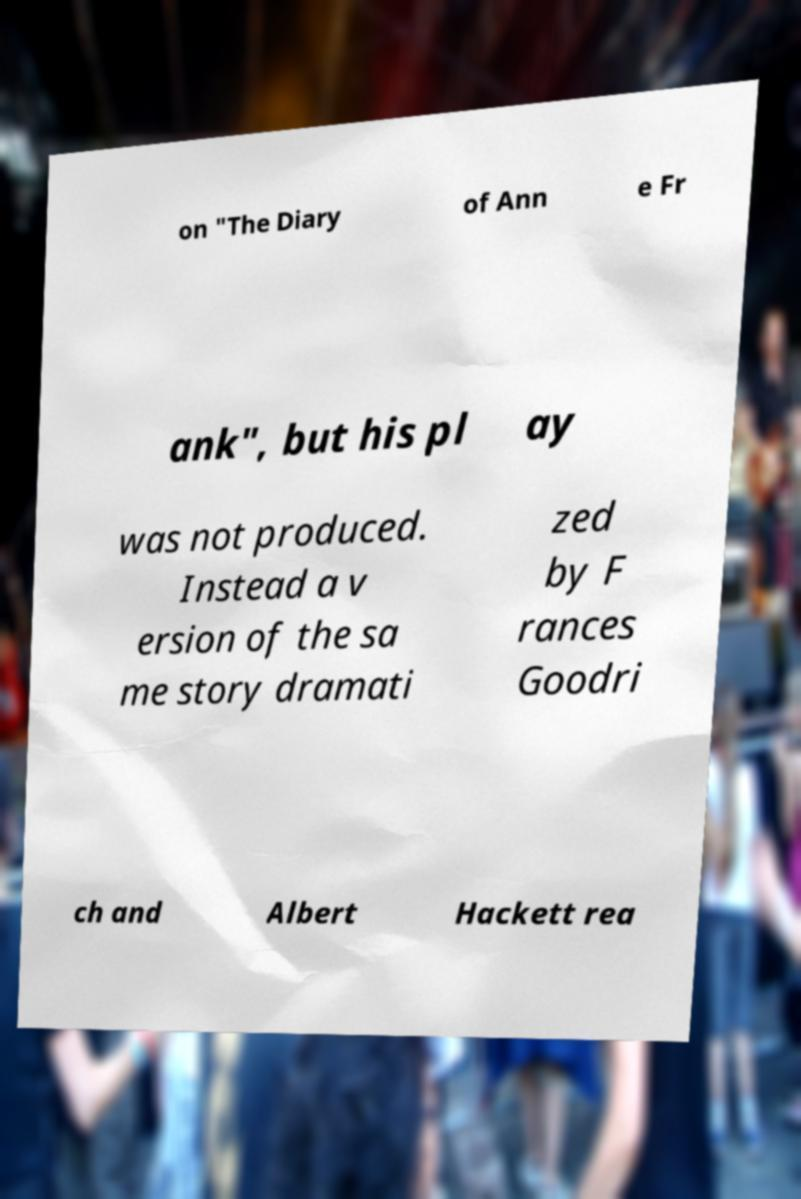Could you extract and type out the text from this image? on "The Diary of Ann e Fr ank", but his pl ay was not produced. Instead a v ersion of the sa me story dramati zed by F rances Goodri ch and Albert Hackett rea 